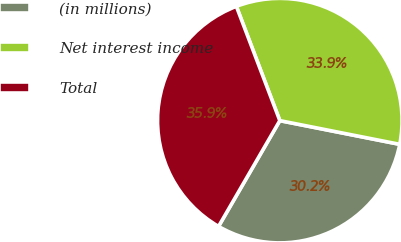<chart> <loc_0><loc_0><loc_500><loc_500><pie_chart><fcel>(in millions)<fcel>Net interest income<fcel>Total<nl><fcel>30.25%<fcel>33.89%<fcel>35.86%<nl></chart> 